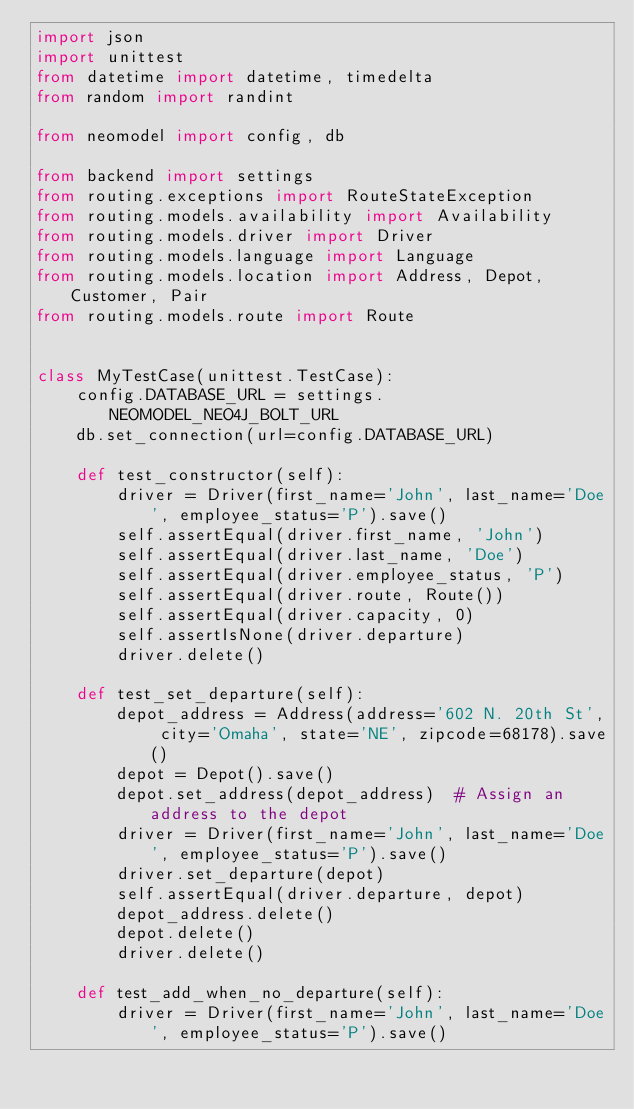<code> <loc_0><loc_0><loc_500><loc_500><_Python_>import json
import unittest
from datetime import datetime, timedelta
from random import randint

from neomodel import config, db

from backend import settings
from routing.exceptions import RouteStateException
from routing.models.availability import Availability
from routing.models.driver import Driver
from routing.models.language import Language
from routing.models.location import Address, Depot, Customer, Pair
from routing.models.route import Route


class MyTestCase(unittest.TestCase):
    config.DATABASE_URL = settings.NEOMODEL_NEO4J_BOLT_URL
    db.set_connection(url=config.DATABASE_URL)

    def test_constructor(self):
        driver = Driver(first_name='John', last_name='Doe', employee_status='P').save()
        self.assertEqual(driver.first_name, 'John')
        self.assertEqual(driver.last_name, 'Doe')
        self.assertEqual(driver.employee_status, 'P')
        self.assertEqual(driver.route, Route())
        self.assertEqual(driver.capacity, 0)
        self.assertIsNone(driver.departure)
        driver.delete()

    def test_set_departure(self):
        depot_address = Address(address='602 N. 20th St', city='Omaha', state='NE', zipcode=68178).save()
        depot = Depot().save()
        depot.set_address(depot_address)  # Assign an address to the depot
        driver = Driver(first_name='John', last_name='Doe', employee_status='P').save()
        driver.set_departure(depot)
        self.assertEqual(driver.departure, depot)
        depot_address.delete()
        depot.delete()
        driver.delete()

    def test_add_when_no_departure(self):
        driver = Driver(first_name='John', last_name='Doe', employee_status='P').save()</code> 